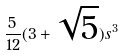Convert formula to latex. <formula><loc_0><loc_0><loc_500><loc_500>\frac { 5 } { 1 2 } ( 3 + \sqrt { 5 } ) s ^ { 3 }</formula> 